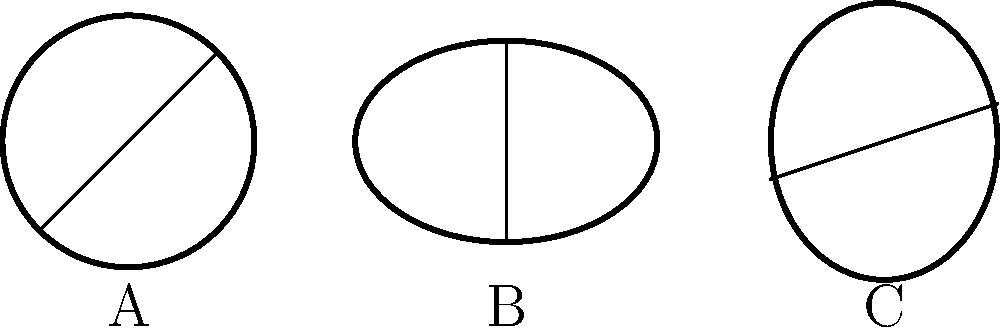As a professional chef specializing in traditional Irish cuisine, identify which of the top-view bread patterns (A, B, or C) represents the traditional Irish soda bread based on its characteristic scoring pattern. To identify the traditional Irish soda bread pattern, let's analyze each shape:

1. Shape A:
   - Circular shape
   - Scored with a deep cross, dividing the bread into four equal sections
   - This scoring pattern is characteristic of Irish soda bread

2. Shape B:
   - Oval shape
   - Single vertical score down the center
   - This pattern is more typical of Irish wheaten bread

3. Shape C:
   - Slightly elongated circular shape
   - Diagonal scoring across the top
   - This pattern resembles a potato bread or farl

The deep cross scoring on a circular loaf (Shape A) is the traditional pattern for Irish soda bread. This cross serves both practical and cultural purposes:
- It helps the bread cook evenly
- It allows the bread to expand properly during baking
- Traditionally, it was believed to "let the fairies out" or ward off evil

Therefore, based on the characteristic scoring pattern, Shape A represents the traditional Irish soda bread.
Answer: A 